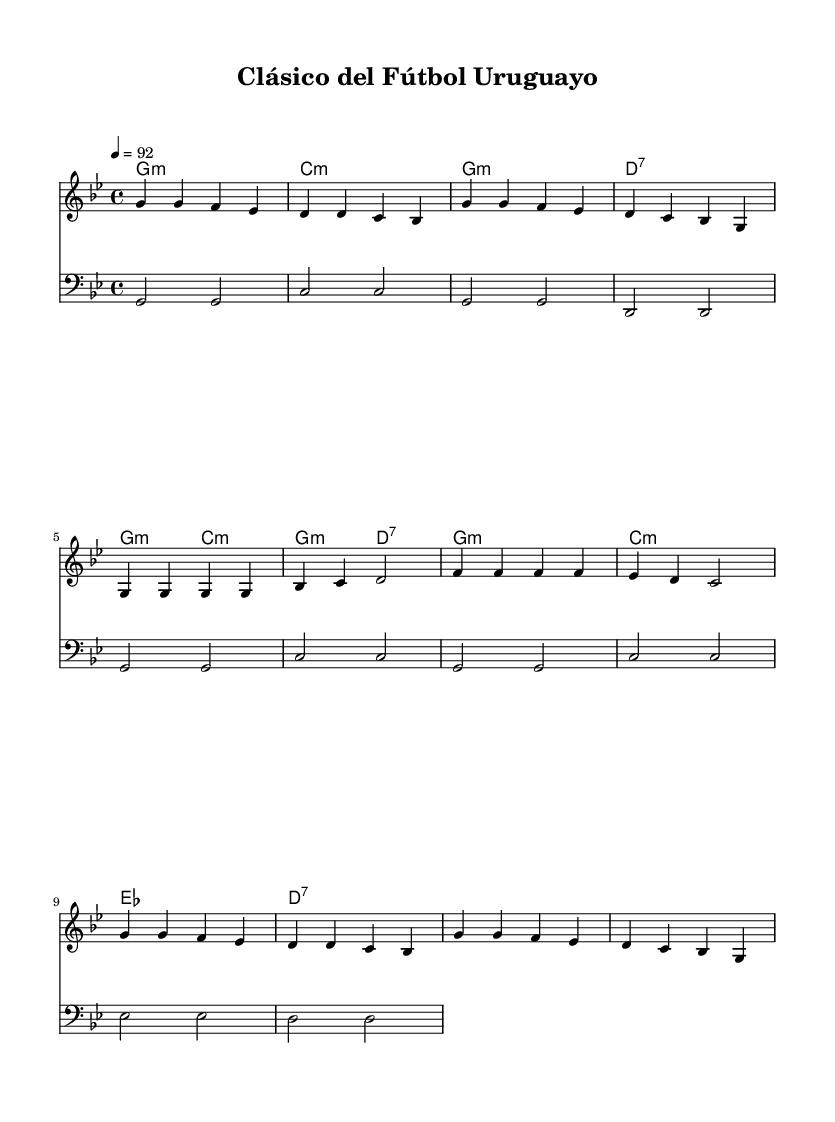What is the key signature of this music? The key signature is G minor, which is indicated by two flats in the key signature (B♭ and E♭).
Answer: G minor What is the time signature of this piece? The time signature is 4/4, indicated at the beginning of the score, which shows that there are four beats in each measure and a quarter note gets one beat.
Answer: 4/4 What is the tempo marking of this piece? The tempo marking is 92 beats per minute, which is stated in the score next to the tempo indication.
Answer: 92 How many measures are in the melody section? By counting the measures in the melody line, there are 14 measures in total before the score concludes with the repeating pattern.
Answer: 14 Which chord is played in the chorus? The chords in the chorus are G minor, C minor, E♭ major, and D7, all of which are repeated in the same sequence.
Answer: G minor, C minor, E♭ major, D7 What is a unique feature of the structure in hip hop regarding this score? A unique feature is the repetitive nature of the chorus, which is characteristic of hip hop music, allowing for a consistent and memorable hook within the song.
Answer: Repetitive chorus 